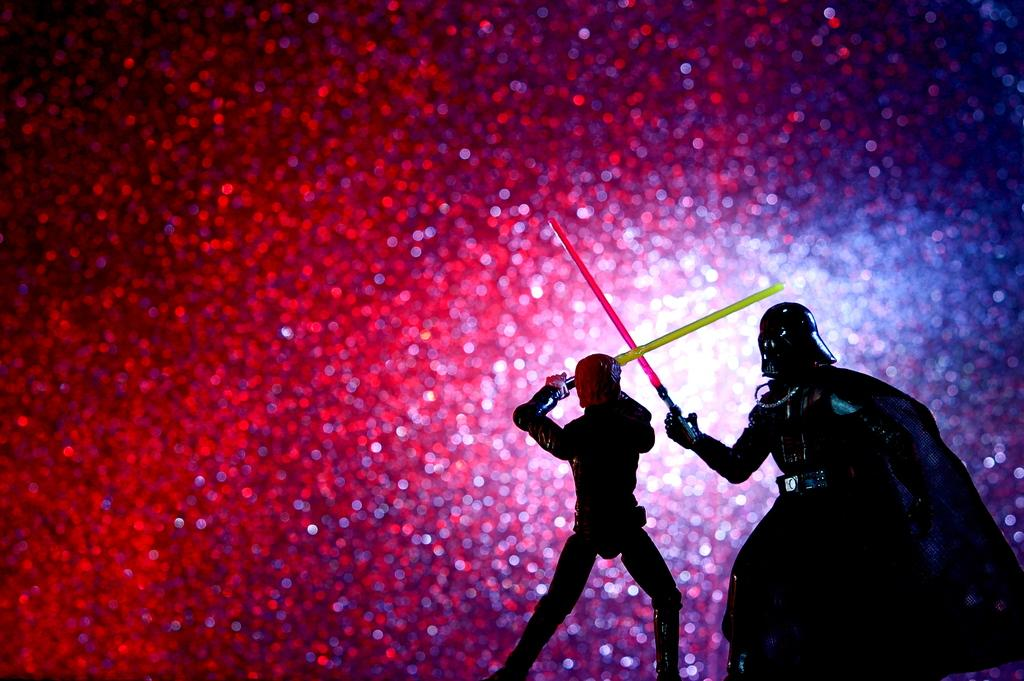What type of image is being described? The image is animated. How many persons are present in the image? There are two persons in the image. What are the persons doing in the image? The persons are fighting each other. What are the persons holding in their hands? The persons are holding swords in their hands. What can be seen in the background of the image? There are red sparkles in the background of the image. What type of pet can be seen playing with a rabbit in the image? There is no pet or rabbit present in the image; it features two persons fighting with swords. What is the weather like in the image? The provided facts do not mention any information about the weather in the image. 